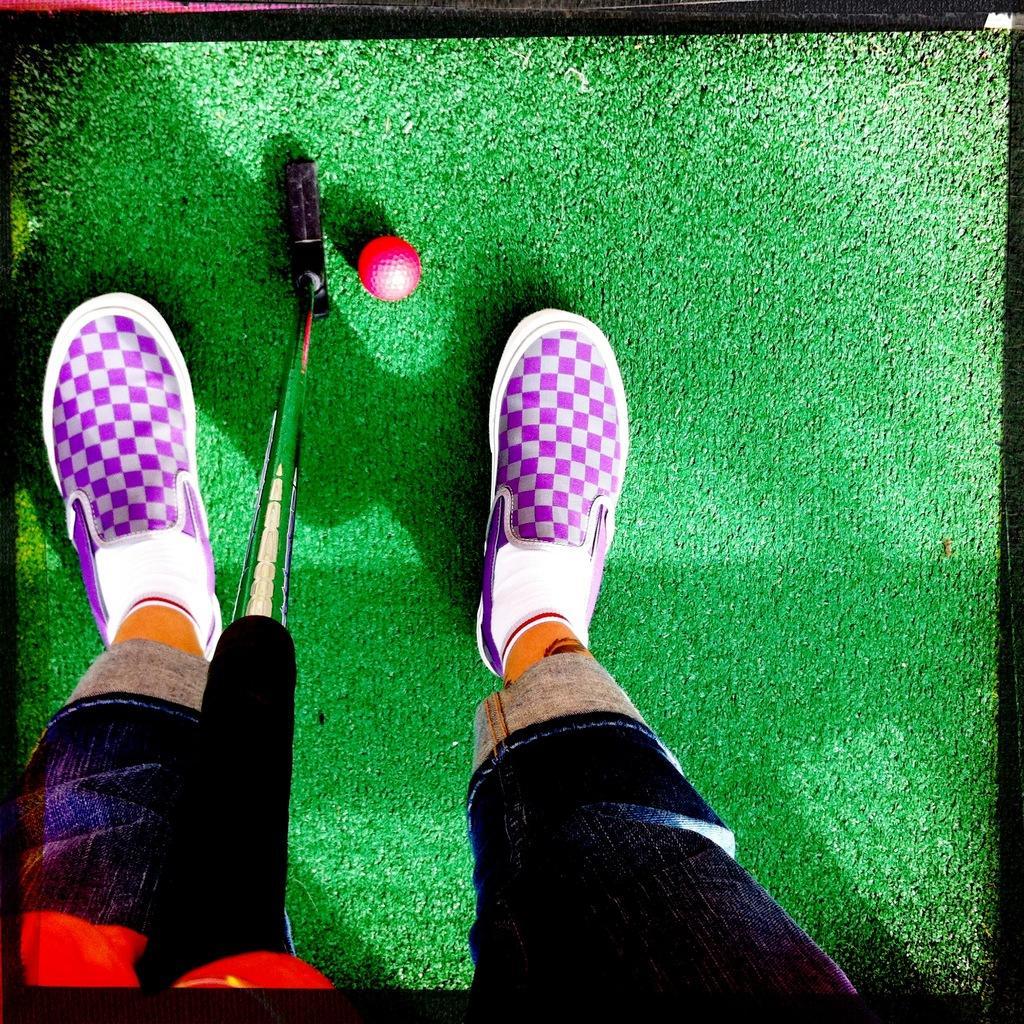How would you summarize this image in a sentence or two? In this image we can see a person standing on the ground by holding billiards stick and there is a ball on the ground. 